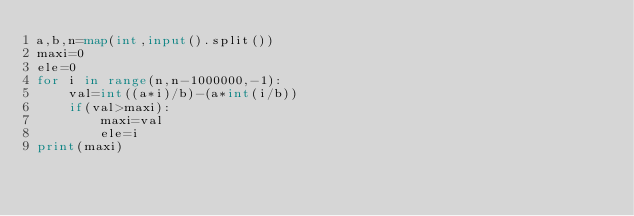<code> <loc_0><loc_0><loc_500><loc_500><_Python_>a,b,n=map(int,input().split())
maxi=0
ele=0
for i in range(n,n-1000000,-1):
    val=int((a*i)/b)-(a*int(i/b))
    if(val>maxi):
        maxi=val
        ele=i
print(maxi)
</code> 